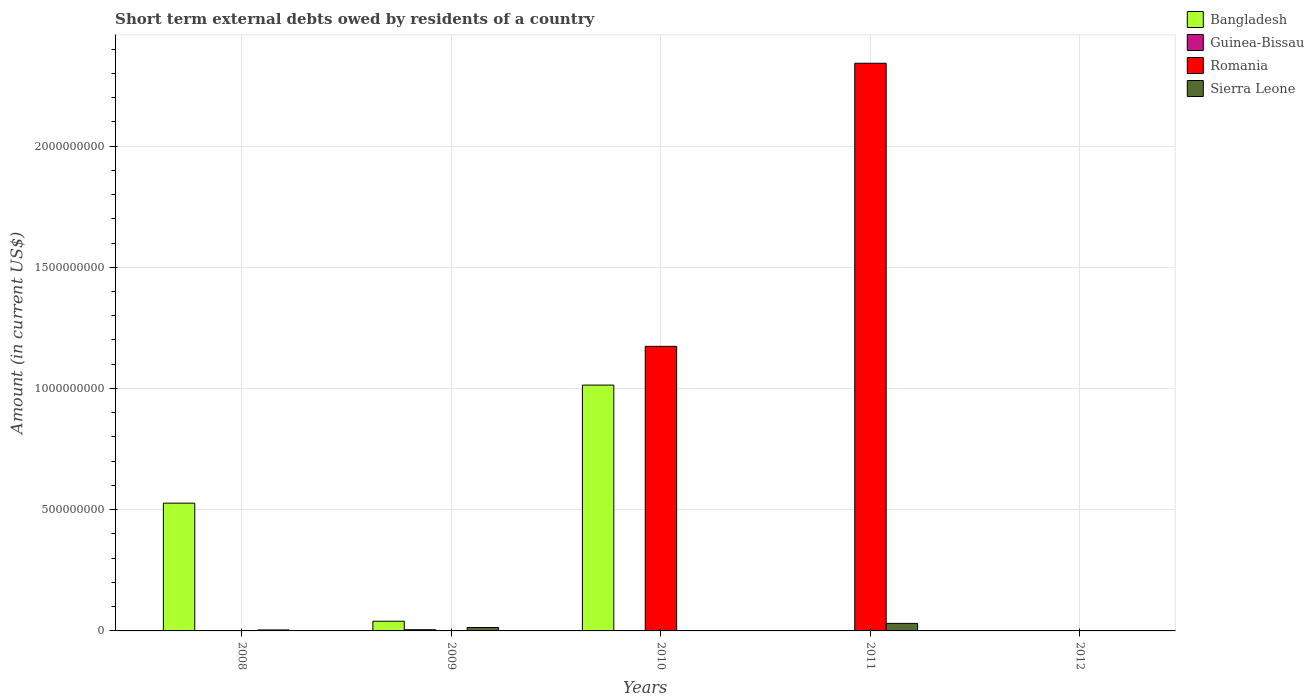Are the number of bars per tick equal to the number of legend labels?
Provide a succinct answer. No. Are the number of bars on each tick of the X-axis equal?
Offer a terse response. No. How many bars are there on the 1st tick from the left?
Offer a very short reply. 2. How many bars are there on the 4th tick from the right?
Give a very brief answer. 3. What is the label of the 1st group of bars from the left?
Your response must be concise. 2008. Across all years, what is the maximum amount of short-term external debts owed by residents in Bangladesh?
Your answer should be compact. 1.01e+09. What is the total amount of short-term external debts owed by residents in Guinea-Bissau in the graph?
Provide a short and direct response. 6.00e+06. What is the difference between the amount of short-term external debts owed by residents in Sierra Leone in 2008 and that in 2011?
Offer a terse response. -2.70e+07. What is the difference between the amount of short-term external debts owed by residents in Bangladesh in 2008 and the amount of short-term external debts owed by residents in Sierra Leone in 2009?
Your response must be concise. 5.13e+08. What is the average amount of short-term external debts owed by residents in Bangladesh per year?
Ensure brevity in your answer.  3.16e+08. In the year 2009, what is the difference between the amount of short-term external debts owed by residents in Bangladesh and amount of short-term external debts owed by residents in Guinea-Bissau?
Offer a very short reply. 3.50e+07. What is the difference between the highest and the second highest amount of short-term external debts owed by residents in Sierra Leone?
Keep it short and to the point. 1.70e+07. What is the difference between the highest and the lowest amount of short-term external debts owed by residents in Romania?
Offer a terse response. 2.34e+09. In how many years, is the amount of short-term external debts owed by residents in Guinea-Bissau greater than the average amount of short-term external debts owed by residents in Guinea-Bissau taken over all years?
Keep it short and to the point. 1. Is it the case that in every year, the sum of the amount of short-term external debts owed by residents in Bangladesh and amount of short-term external debts owed by residents in Sierra Leone is greater than the sum of amount of short-term external debts owed by residents in Romania and amount of short-term external debts owed by residents in Guinea-Bissau?
Keep it short and to the point. No. Are all the bars in the graph horizontal?
Provide a succinct answer. No. How many years are there in the graph?
Offer a very short reply. 5. Does the graph contain any zero values?
Your answer should be compact. Yes. Does the graph contain grids?
Your response must be concise. Yes. Where does the legend appear in the graph?
Keep it short and to the point. Top right. How are the legend labels stacked?
Offer a very short reply. Vertical. What is the title of the graph?
Your answer should be compact. Short term external debts owed by residents of a country. Does "Tuvalu" appear as one of the legend labels in the graph?
Provide a short and direct response. No. What is the label or title of the X-axis?
Give a very brief answer. Years. What is the Amount (in current US$) of Bangladesh in 2008?
Make the answer very short. 5.27e+08. What is the Amount (in current US$) in Guinea-Bissau in 2008?
Keep it short and to the point. 0. What is the Amount (in current US$) in Sierra Leone in 2008?
Give a very brief answer. 4.00e+06. What is the Amount (in current US$) in Bangladesh in 2009?
Ensure brevity in your answer.  4.00e+07. What is the Amount (in current US$) in Romania in 2009?
Offer a terse response. 0. What is the Amount (in current US$) in Sierra Leone in 2009?
Ensure brevity in your answer.  1.40e+07. What is the Amount (in current US$) in Bangladesh in 2010?
Your response must be concise. 1.01e+09. What is the Amount (in current US$) of Romania in 2010?
Your answer should be compact. 1.17e+09. What is the Amount (in current US$) of Bangladesh in 2011?
Offer a terse response. 0. What is the Amount (in current US$) in Romania in 2011?
Your response must be concise. 2.34e+09. What is the Amount (in current US$) of Sierra Leone in 2011?
Offer a terse response. 3.10e+07. What is the Amount (in current US$) in Bangladesh in 2012?
Give a very brief answer. 0. What is the Amount (in current US$) in Sierra Leone in 2012?
Give a very brief answer. 0. Across all years, what is the maximum Amount (in current US$) in Bangladesh?
Offer a very short reply. 1.01e+09. Across all years, what is the maximum Amount (in current US$) in Guinea-Bissau?
Your response must be concise. 5.00e+06. Across all years, what is the maximum Amount (in current US$) in Romania?
Give a very brief answer. 2.34e+09. Across all years, what is the maximum Amount (in current US$) in Sierra Leone?
Provide a short and direct response. 3.10e+07. Across all years, what is the minimum Amount (in current US$) in Bangladesh?
Offer a very short reply. 0. Across all years, what is the minimum Amount (in current US$) in Romania?
Offer a terse response. 0. What is the total Amount (in current US$) in Bangladesh in the graph?
Your answer should be compact. 1.58e+09. What is the total Amount (in current US$) in Romania in the graph?
Make the answer very short. 3.52e+09. What is the total Amount (in current US$) in Sierra Leone in the graph?
Provide a short and direct response. 4.90e+07. What is the difference between the Amount (in current US$) in Bangladesh in 2008 and that in 2009?
Your answer should be compact. 4.87e+08. What is the difference between the Amount (in current US$) in Sierra Leone in 2008 and that in 2009?
Offer a terse response. -1.00e+07. What is the difference between the Amount (in current US$) of Bangladesh in 2008 and that in 2010?
Give a very brief answer. -4.87e+08. What is the difference between the Amount (in current US$) of Sierra Leone in 2008 and that in 2011?
Provide a succinct answer. -2.70e+07. What is the difference between the Amount (in current US$) in Bangladesh in 2009 and that in 2010?
Offer a terse response. -9.74e+08. What is the difference between the Amount (in current US$) of Sierra Leone in 2009 and that in 2011?
Make the answer very short. -1.70e+07. What is the difference between the Amount (in current US$) in Guinea-Bissau in 2009 and that in 2012?
Give a very brief answer. 4.00e+06. What is the difference between the Amount (in current US$) of Romania in 2010 and that in 2011?
Your response must be concise. -1.17e+09. What is the difference between the Amount (in current US$) in Bangladesh in 2008 and the Amount (in current US$) in Guinea-Bissau in 2009?
Ensure brevity in your answer.  5.22e+08. What is the difference between the Amount (in current US$) of Bangladesh in 2008 and the Amount (in current US$) of Sierra Leone in 2009?
Provide a succinct answer. 5.13e+08. What is the difference between the Amount (in current US$) of Bangladesh in 2008 and the Amount (in current US$) of Romania in 2010?
Provide a short and direct response. -6.47e+08. What is the difference between the Amount (in current US$) of Bangladesh in 2008 and the Amount (in current US$) of Romania in 2011?
Your answer should be very brief. -1.81e+09. What is the difference between the Amount (in current US$) of Bangladesh in 2008 and the Amount (in current US$) of Sierra Leone in 2011?
Offer a terse response. 4.96e+08. What is the difference between the Amount (in current US$) in Bangladesh in 2008 and the Amount (in current US$) in Guinea-Bissau in 2012?
Give a very brief answer. 5.26e+08. What is the difference between the Amount (in current US$) of Bangladesh in 2009 and the Amount (in current US$) of Romania in 2010?
Keep it short and to the point. -1.13e+09. What is the difference between the Amount (in current US$) of Guinea-Bissau in 2009 and the Amount (in current US$) of Romania in 2010?
Your response must be concise. -1.17e+09. What is the difference between the Amount (in current US$) of Bangladesh in 2009 and the Amount (in current US$) of Romania in 2011?
Give a very brief answer. -2.30e+09. What is the difference between the Amount (in current US$) of Bangladesh in 2009 and the Amount (in current US$) of Sierra Leone in 2011?
Offer a terse response. 9.00e+06. What is the difference between the Amount (in current US$) in Guinea-Bissau in 2009 and the Amount (in current US$) in Romania in 2011?
Your answer should be compact. -2.34e+09. What is the difference between the Amount (in current US$) of Guinea-Bissau in 2009 and the Amount (in current US$) of Sierra Leone in 2011?
Give a very brief answer. -2.60e+07. What is the difference between the Amount (in current US$) of Bangladesh in 2009 and the Amount (in current US$) of Guinea-Bissau in 2012?
Your answer should be very brief. 3.90e+07. What is the difference between the Amount (in current US$) of Bangladesh in 2010 and the Amount (in current US$) of Romania in 2011?
Make the answer very short. -1.33e+09. What is the difference between the Amount (in current US$) of Bangladesh in 2010 and the Amount (in current US$) of Sierra Leone in 2011?
Provide a short and direct response. 9.83e+08. What is the difference between the Amount (in current US$) of Romania in 2010 and the Amount (in current US$) of Sierra Leone in 2011?
Your answer should be very brief. 1.14e+09. What is the difference between the Amount (in current US$) of Bangladesh in 2010 and the Amount (in current US$) of Guinea-Bissau in 2012?
Provide a short and direct response. 1.01e+09. What is the average Amount (in current US$) of Bangladesh per year?
Provide a short and direct response. 3.16e+08. What is the average Amount (in current US$) in Guinea-Bissau per year?
Provide a succinct answer. 1.20e+06. What is the average Amount (in current US$) in Romania per year?
Offer a very short reply. 7.03e+08. What is the average Amount (in current US$) in Sierra Leone per year?
Keep it short and to the point. 9.80e+06. In the year 2008, what is the difference between the Amount (in current US$) of Bangladesh and Amount (in current US$) of Sierra Leone?
Provide a short and direct response. 5.23e+08. In the year 2009, what is the difference between the Amount (in current US$) of Bangladesh and Amount (in current US$) of Guinea-Bissau?
Make the answer very short. 3.50e+07. In the year 2009, what is the difference between the Amount (in current US$) in Bangladesh and Amount (in current US$) in Sierra Leone?
Keep it short and to the point. 2.60e+07. In the year 2009, what is the difference between the Amount (in current US$) of Guinea-Bissau and Amount (in current US$) of Sierra Leone?
Keep it short and to the point. -9.00e+06. In the year 2010, what is the difference between the Amount (in current US$) in Bangladesh and Amount (in current US$) in Romania?
Your response must be concise. -1.60e+08. In the year 2011, what is the difference between the Amount (in current US$) in Romania and Amount (in current US$) in Sierra Leone?
Give a very brief answer. 2.31e+09. What is the ratio of the Amount (in current US$) in Bangladesh in 2008 to that in 2009?
Offer a terse response. 13.18. What is the ratio of the Amount (in current US$) in Sierra Leone in 2008 to that in 2009?
Offer a very short reply. 0.29. What is the ratio of the Amount (in current US$) in Bangladesh in 2008 to that in 2010?
Keep it short and to the point. 0.52. What is the ratio of the Amount (in current US$) of Sierra Leone in 2008 to that in 2011?
Provide a short and direct response. 0.13. What is the ratio of the Amount (in current US$) in Bangladesh in 2009 to that in 2010?
Provide a short and direct response. 0.04. What is the ratio of the Amount (in current US$) in Sierra Leone in 2009 to that in 2011?
Give a very brief answer. 0.45. What is the ratio of the Amount (in current US$) of Guinea-Bissau in 2009 to that in 2012?
Your answer should be compact. 5. What is the ratio of the Amount (in current US$) of Romania in 2010 to that in 2011?
Your response must be concise. 0.5. What is the difference between the highest and the second highest Amount (in current US$) in Bangladesh?
Provide a succinct answer. 4.87e+08. What is the difference between the highest and the second highest Amount (in current US$) in Sierra Leone?
Provide a short and direct response. 1.70e+07. What is the difference between the highest and the lowest Amount (in current US$) in Bangladesh?
Offer a terse response. 1.01e+09. What is the difference between the highest and the lowest Amount (in current US$) of Guinea-Bissau?
Offer a very short reply. 5.00e+06. What is the difference between the highest and the lowest Amount (in current US$) of Romania?
Provide a short and direct response. 2.34e+09. What is the difference between the highest and the lowest Amount (in current US$) in Sierra Leone?
Provide a succinct answer. 3.10e+07. 